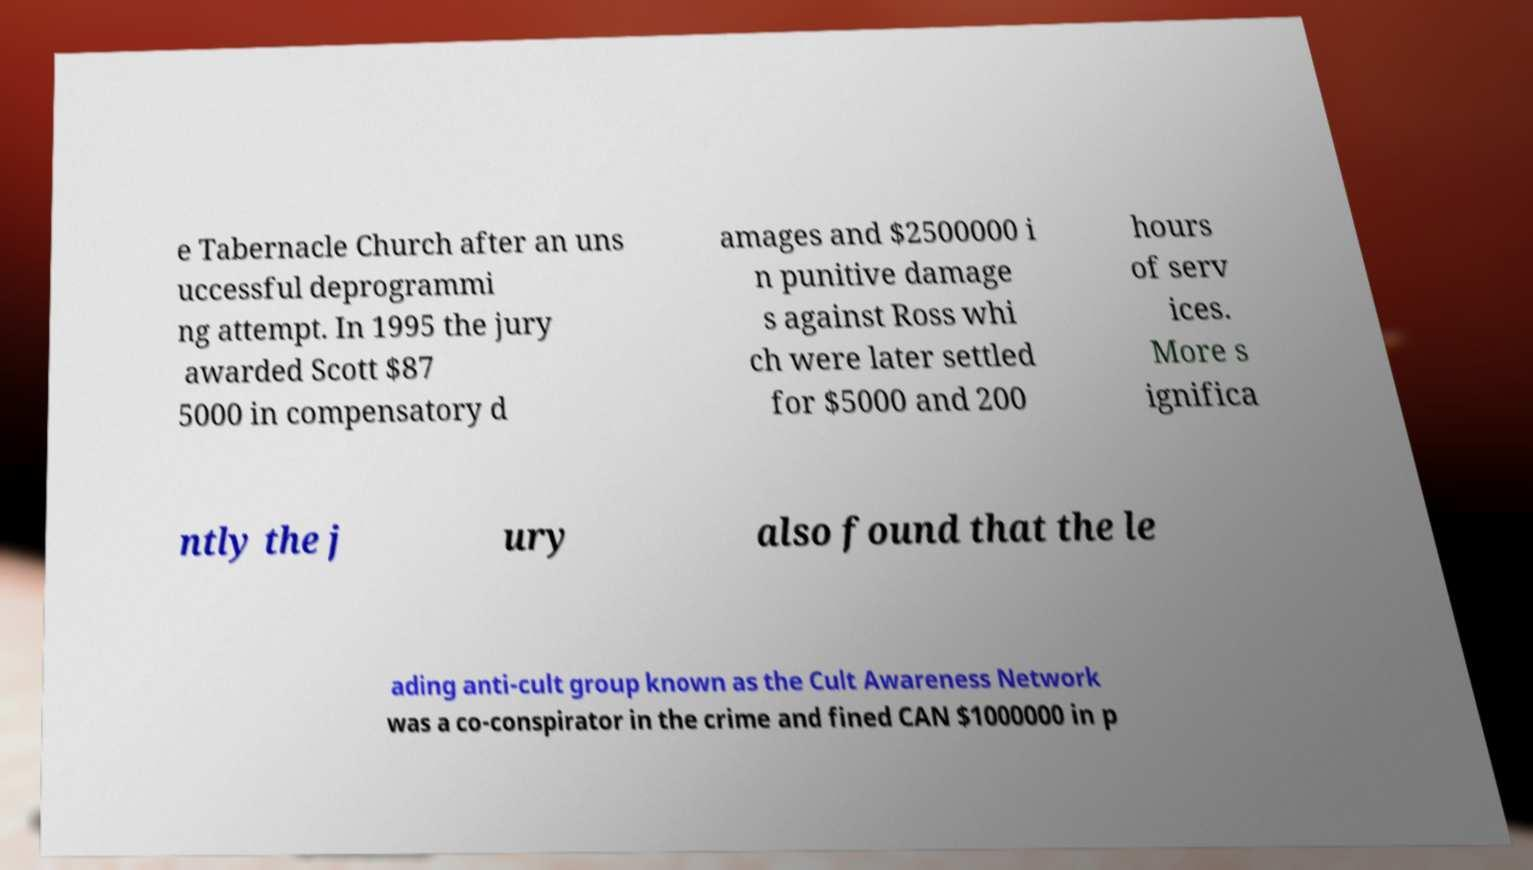Could you extract and type out the text from this image? e Tabernacle Church after an uns uccessful deprogrammi ng attempt. In 1995 the jury awarded Scott $87 5000 in compensatory d amages and $2500000 i n punitive damage s against Ross whi ch were later settled for $5000 and 200 hours of serv ices. More s ignifica ntly the j ury also found that the le ading anti-cult group known as the Cult Awareness Network was a co-conspirator in the crime and fined CAN $1000000 in p 